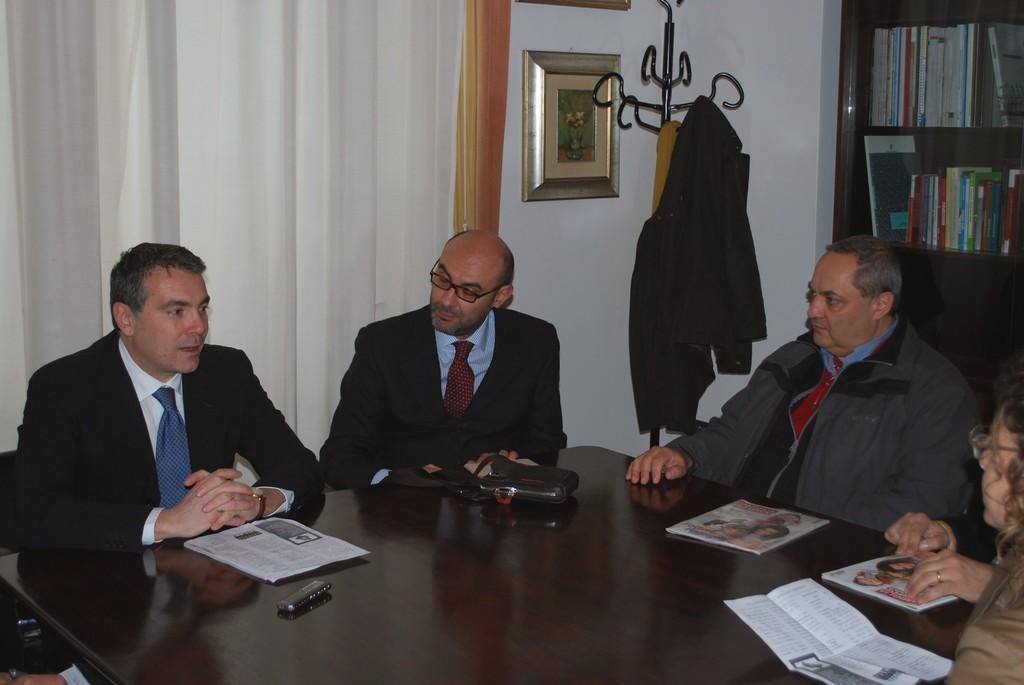Could you give a brief overview of what you see in this image? In this image I can see four persons are sitting and I can see two of them are wearing formal dress. In the front of them I can see a table and on it I can see few papers, two magazines, a bag and a black colour thing. In the background I can see white colour curtains, a stand and on it I can see a black colour jacket. I can also see a frame on the wall and on the right side of this image I can see number of books on the shelves. 